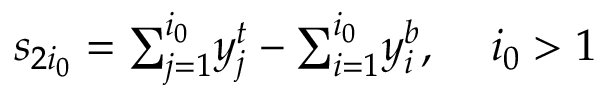<formula> <loc_0><loc_0><loc_500><loc_500>s _ { 2 i _ { 0 } } = { \sum _ { j = 1 } ^ { i _ { 0 } } } y _ { j } ^ { t } - { \sum _ { i = 1 } ^ { i _ { 0 } } } y _ { i } ^ { b } , \, \ i _ { 0 } > 1</formula> 